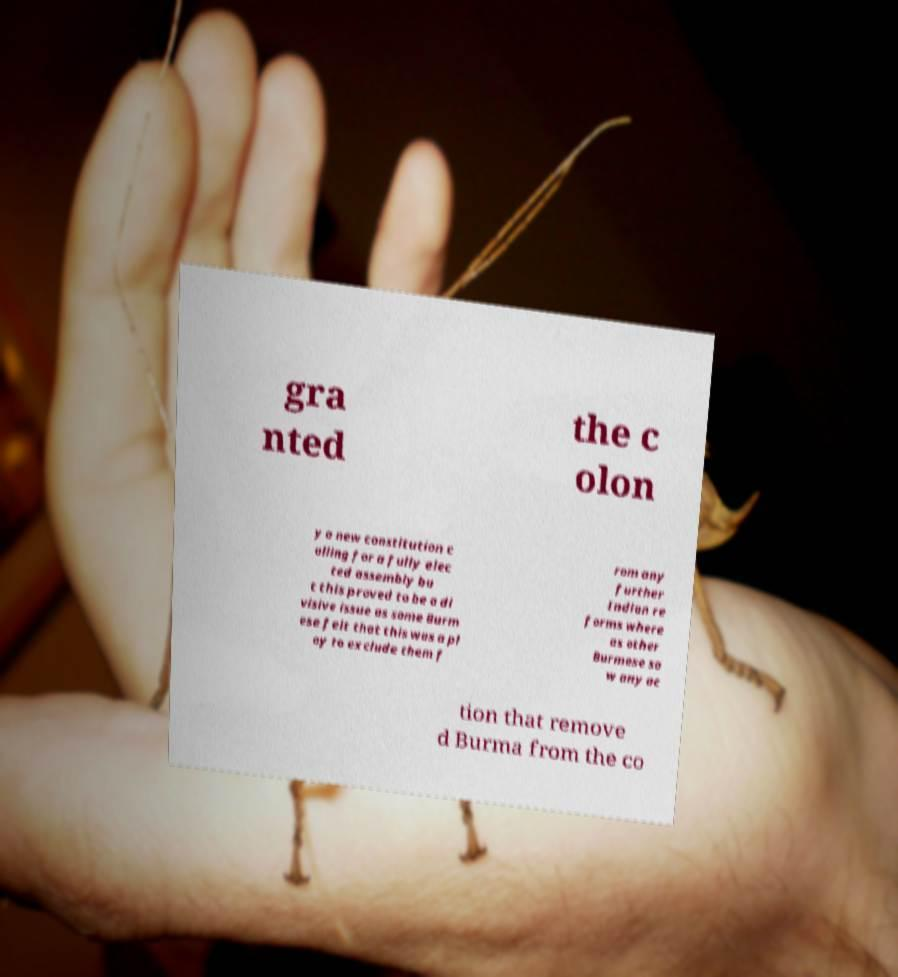Could you assist in decoding the text presented in this image and type it out clearly? gra nted the c olon y a new constitution c alling for a fully elec ted assembly bu t this proved to be a di visive issue as some Burm ese felt that this was a pl oy to exclude them f rom any further Indian re forms where as other Burmese sa w any ac tion that remove d Burma from the co 